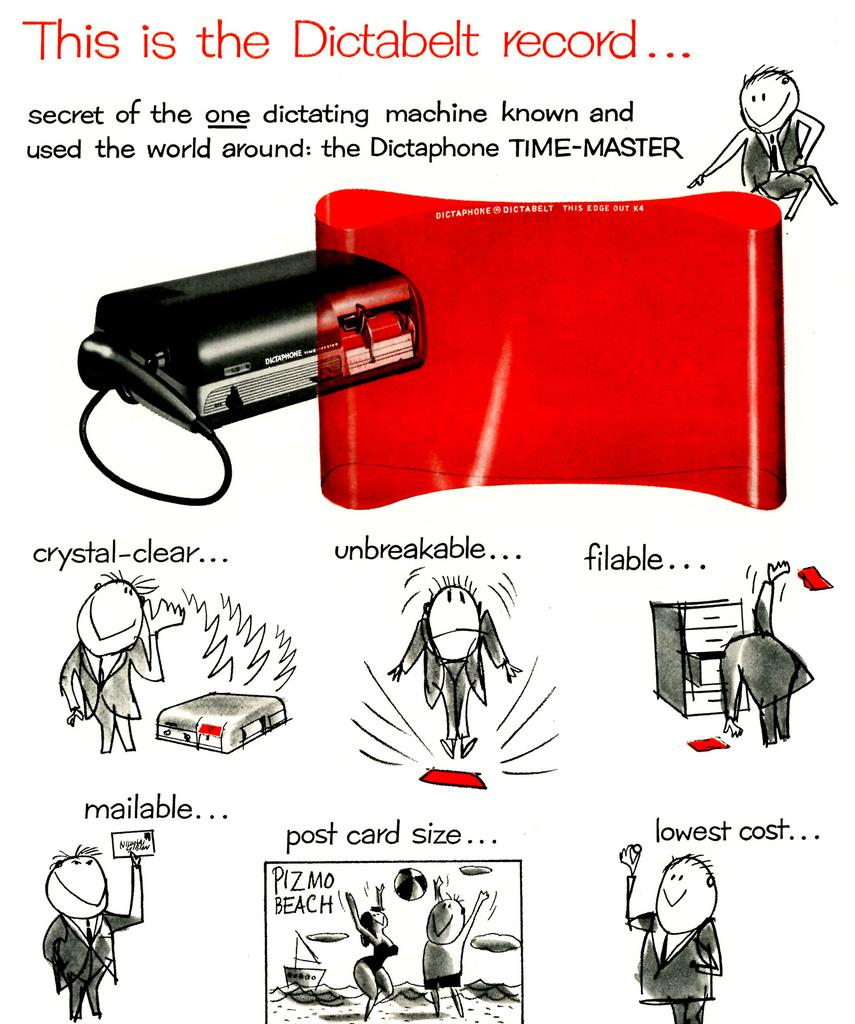<image>
Provide a brief description of the given image. Poster that contains cartoons about the dictabelt record 